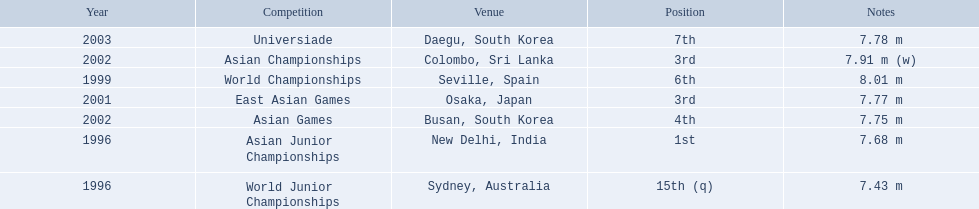What are the competitions that huang le participated in? World Junior Championships, Asian Junior Championships, World Championships, East Asian Games, Asian Championships, Asian Games, Universiade. Which competitions did he participate in 2002 Asian Championships, Asian Games. What are the lengths of his jumps that year? 7.91 m (w), 7.75 m. What is the longest length of a jump? 7.91 m (w). 